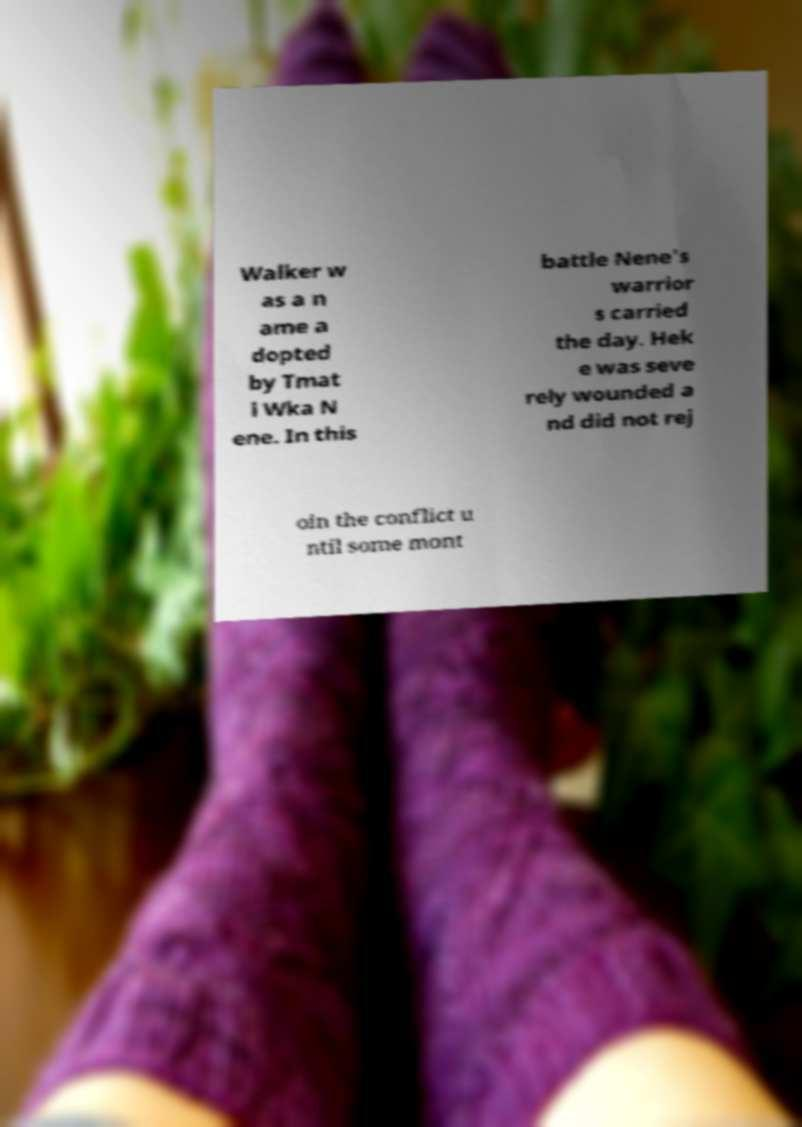There's text embedded in this image that I need extracted. Can you transcribe it verbatim? Walker w as a n ame a dopted by Tmat i Wka N ene. In this battle Nene's warrior s carried the day. Hek e was seve rely wounded a nd did not rej oin the conflict u ntil some mont 